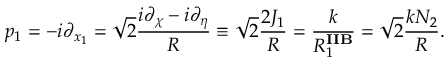<formula> <loc_0><loc_0><loc_500><loc_500>p _ { 1 } = - i \partial _ { x _ { 1 } } = \sqrt { 2 } \frac { i \partial _ { \chi } - i \partial _ { \eta } } { R } \equiv \sqrt { 2 } \frac { 2 J _ { 1 } } { R } = \frac { k } { R _ { 1 } ^ { I I B } } = \sqrt { 2 } \frac { k N _ { 2 } } { R } .</formula> 